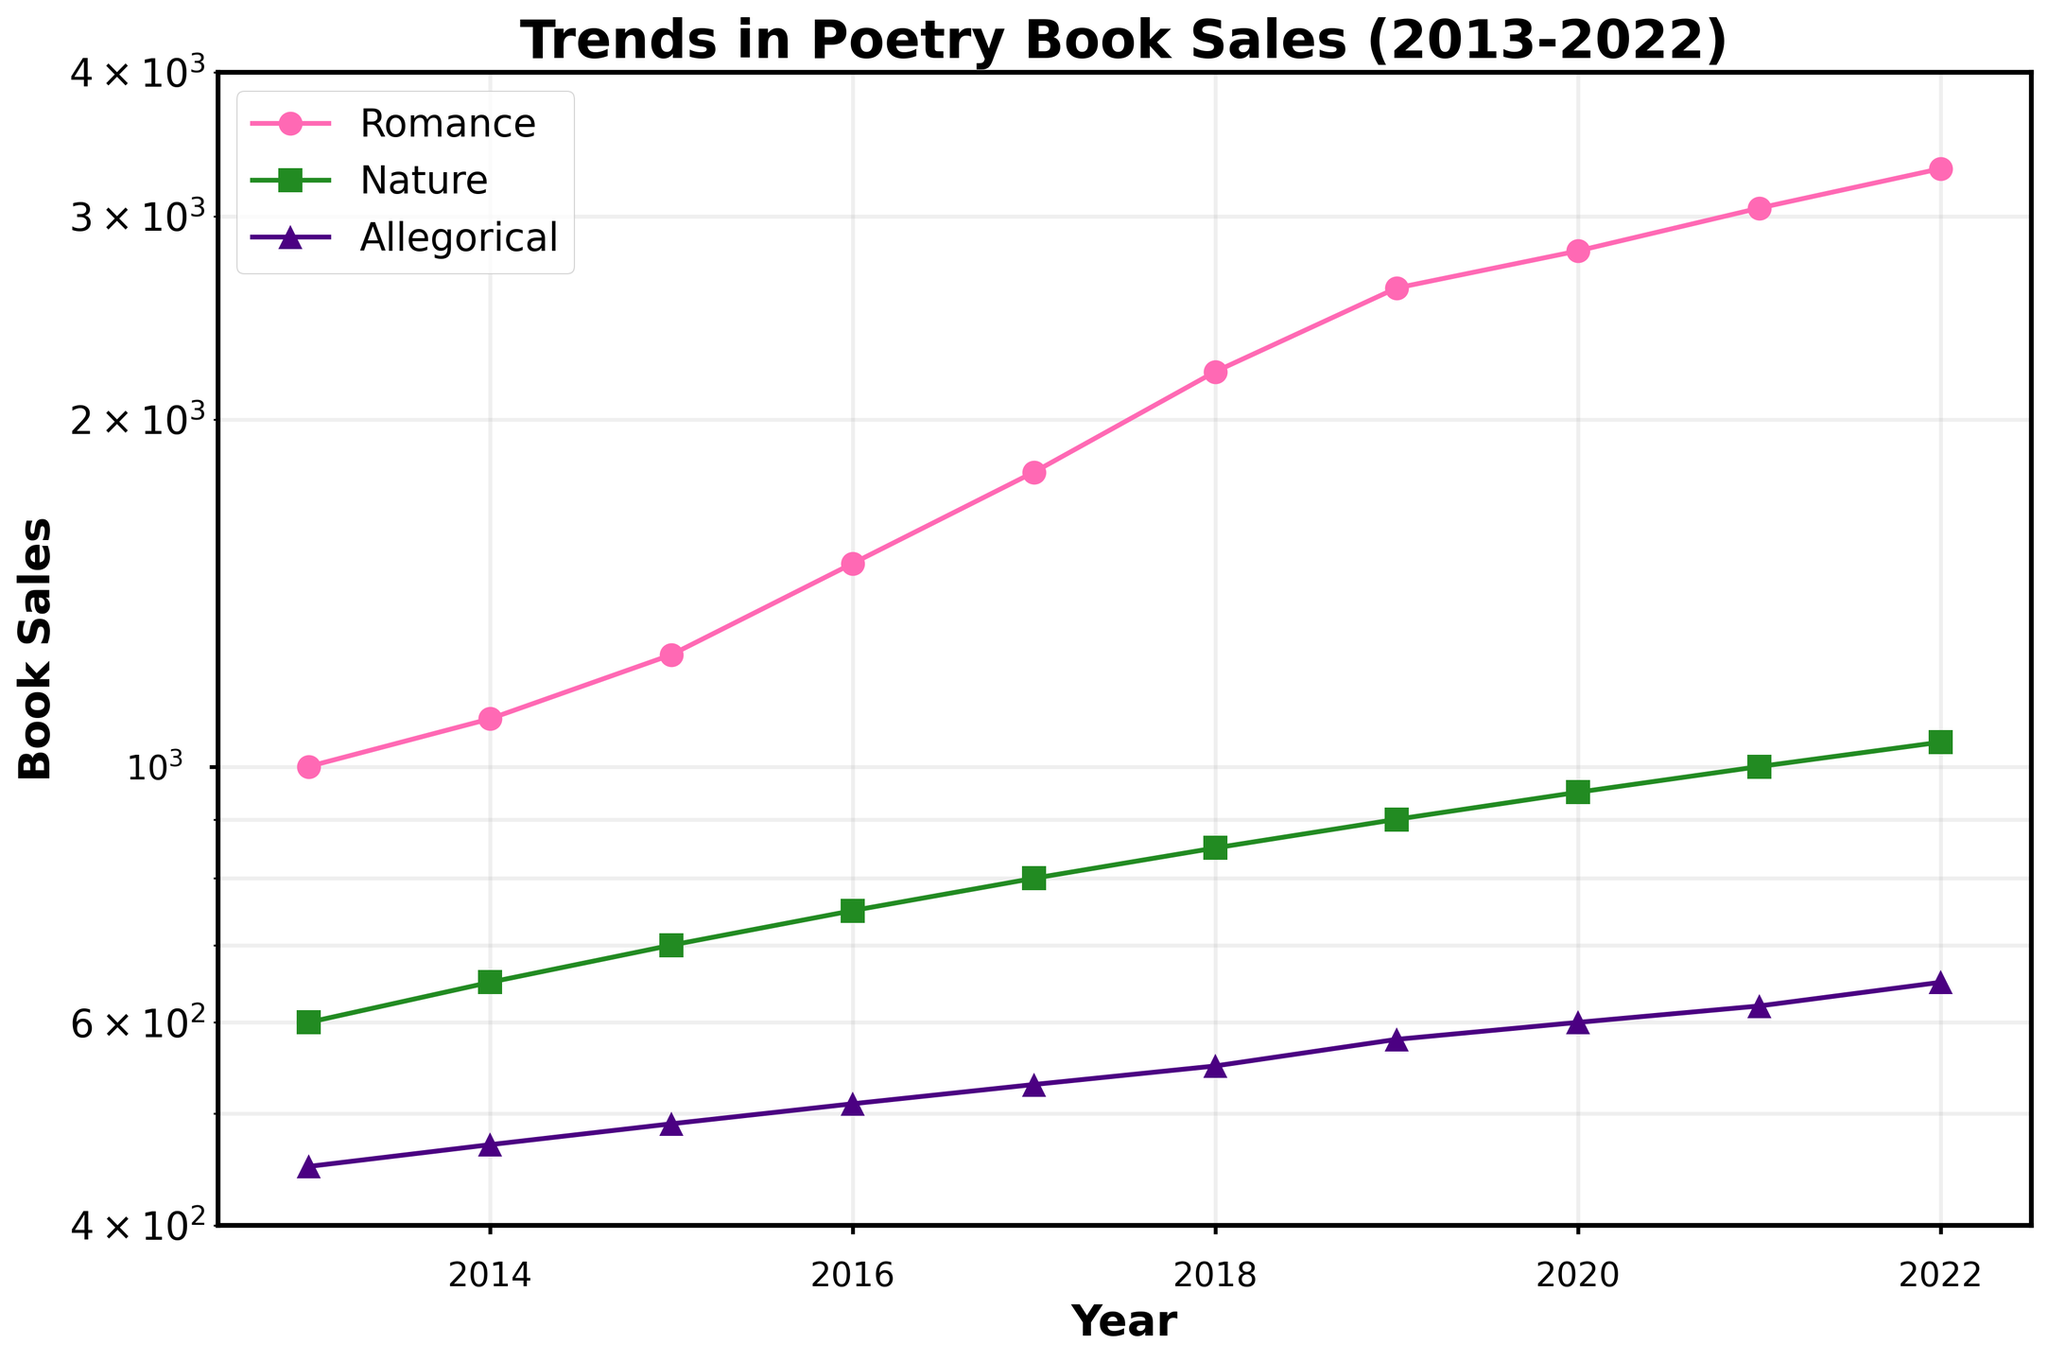What is the title of the figure? The title is displayed at the top of the figure and provides an overview of what the plot represents.
Answer: Trends in Poetry Book Sales (2013-2022) What are the genres shown in the plot? The genres are given in the legend located at the upper left of the plot, corresponding to different colors and markers.
Answer: Romance, Nature, Allegorical Which genre had the highest book sales in 2022? By looking at the lines and their intersection with the year 2022 on the x-axis, the line for Romance is the highest in the y-axis value.
Answer: Romance What is the range of the y-axis in the plot? The range is shown from the bottom to the top of the y-axis.
Answer: 400 to 4000 Between which years did the Nature genre see the most significant increase in book sales? By observing the Nature line (green color), the largest increase in slope occurs between 2017 and 2018.
Answer: 2017 to 2018 By how much did the Romance genre book sales increase from 2014 to 2015? The y-values for Romance in 2014 and 2015 are 1100 and 1250, respectively. The difference is 1250 - 1100.
Answer: 150 Which genre has the smallest data points in all years? By checking the y-values for each year, the Allegorical line (purple color) consistently has the lowest values.
Answer: Allegorical What is the sales difference between Romance and Allegorical genres in 2020? The y-values for these genres in 2020 are 2800 for Romance and 600 for Allegorical. The difference is 2800 - 600.
Answer: 2200 Which year had the smallest gap between Romance and Allegorical book sales? By comparing the vertical distances between the Romance and Allegorical lines for each year, the gap is smallest in 2013.
Answer: 2013 Among the three genres, which one had the most consistent increase in sales over the years? By analyzing the smoothness and equal upward trend of the lines, Nature shows a consistent increase without drastic changes in slope.
Answer: Nature 